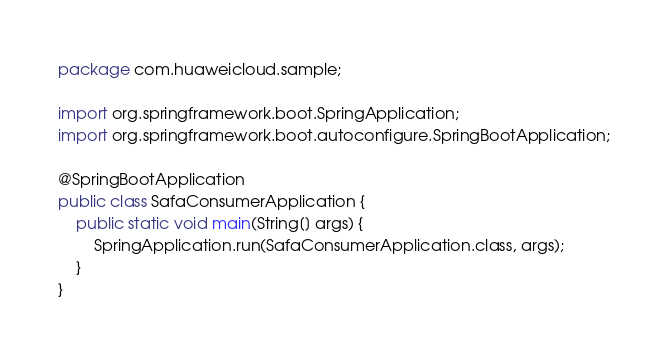<code> <loc_0><loc_0><loc_500><loc_500><_Java_>package com.huaweicloud.sample;

import org.springframework.boot.SpringApplication;
import org.springframework.boot.autoconfigure.SpringBootApplication;

@SpringBootApplication
public class SafaConsumerApplication {
    public static void main(String[] args) {
        SpringApplication.run(SafaConsumerApplication.class, args);
    }
}
</code> 